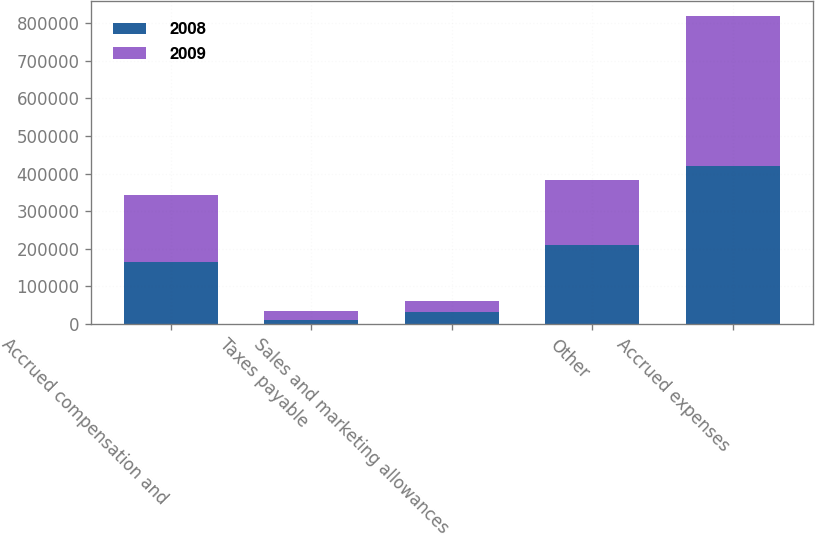Convert chart. <chart><loc_0><loc_0><loc_500><loc_500><stacked_bar_chart><ecel><fcel>Accrued compensation and<fcel>Taxes payable<fcel>Sales and marketing allowances<fcel>Other<fcel>Accrued expenses<nl><fcel>2008<fcel>164352<fcel>11879<fcel>32774<fcel>210641<fcel>419646<nl><fcel>2009<fcel>177760<fcel>21760<fcel>28127<fcel>172322<fcel>399969<nl></chart> 